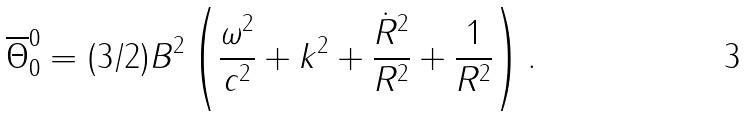Convert formula to latex. <formula><loc_0><loc_0><loc_500><loc_500>\overline { \Theta } ^ { 0 } _ { 0 } = ( 3 / 2 ) B ^ { 2 } \left ( \frac { \omega ^ { 2 } } { c ^ { 2 } } + k ^ { 2 } + \frac { \dot { R } ^ { 2 } } { R ^ { 2 } } + \frac { 1 } { R ^ { 2 } } \right ) .</formula> 